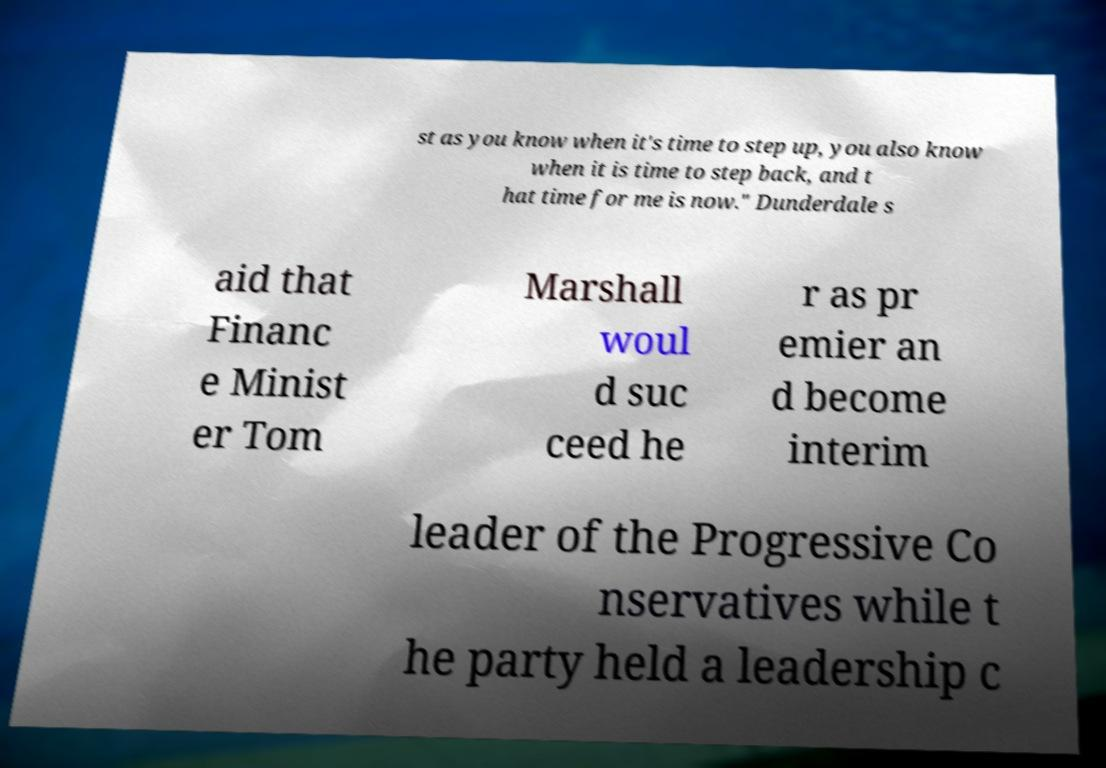Can you read and provide the text displayed in the image?This photo seems to have some interesting text. Can you extract and type it out for me? st as you know when it's time to step up, you also know when it is time to step back, and t hat time for me is now." Dunderdale s aid that Financ e Minist er Tom Marshall woul d suc ceed he r as pr emier an d become interim leader of the Progressive Co nservatives while t he party held a leadership c 